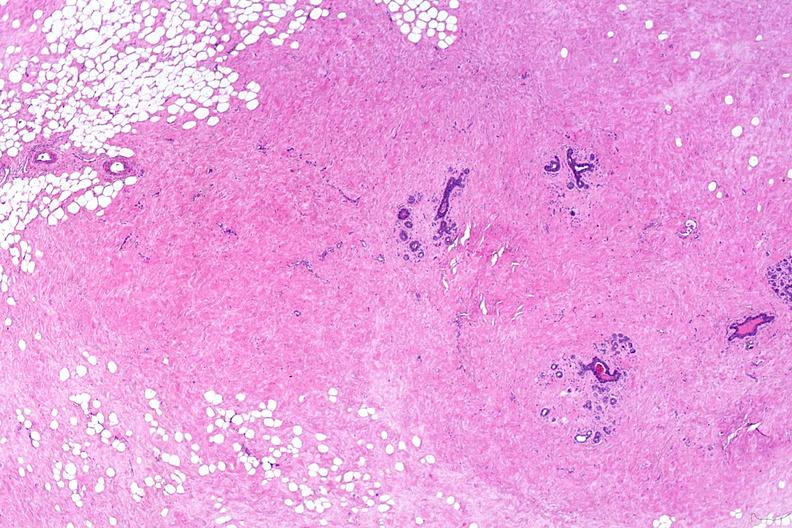where is this from?
Answer the question using a single word or phrase. Female reproductive system 